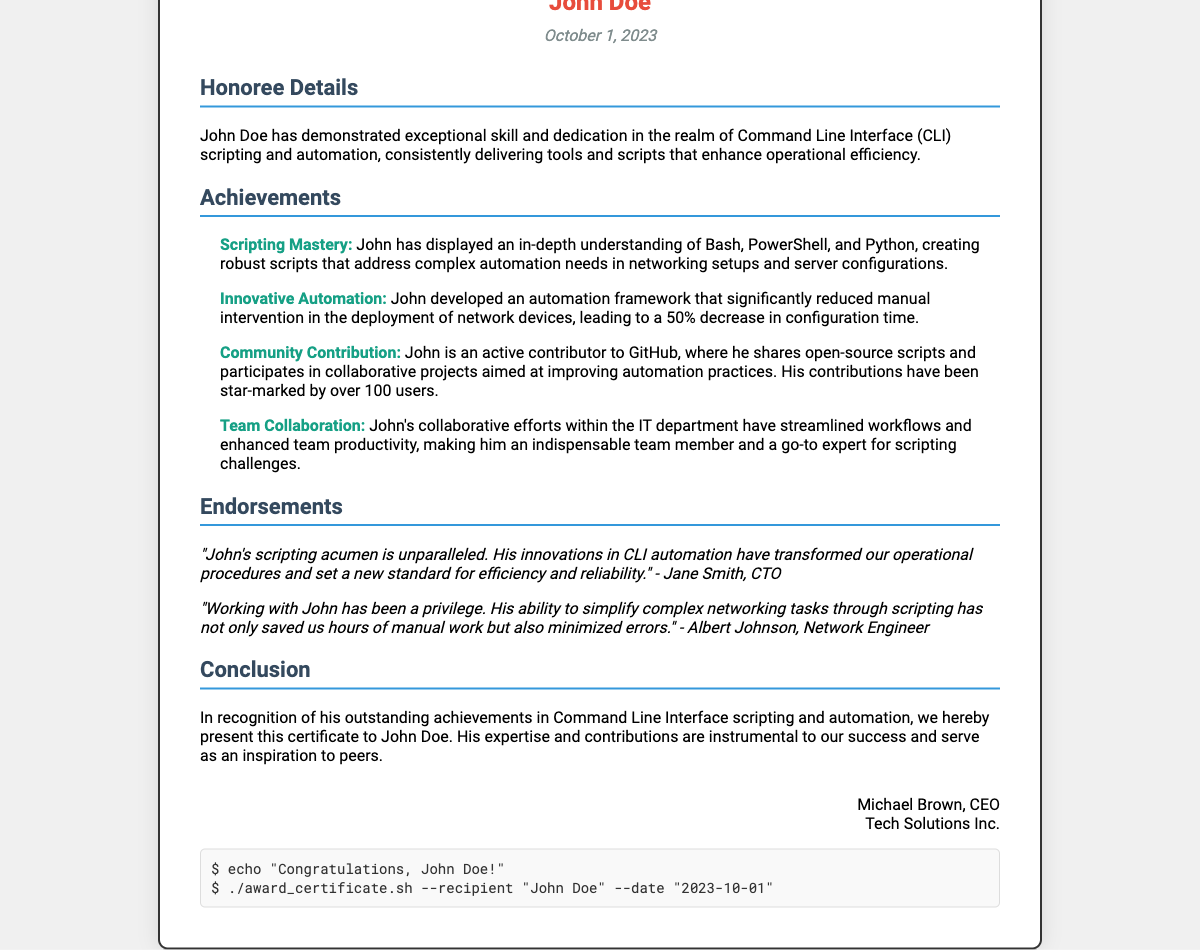What is the title of the certificate? The title clearly states the recognition given for CLI scripting and automation.
Answer: Recognition for Outstanding Command Line Interface Scripting and Automation Who is the recipient of the certificate? The document specifically names the individual who received the certificate.
Answer: John Doe What date is listed on the certificate? The document provides the exact date the certificate was awarded.
Answer: October 1, 2023 What programming languages are mentioned in the achievements? The document lists the programming languages in which the recipient has demonstrated skill.
Answer: Bash, PowerShell, Python What is the percentage decrease in configuration time due to automation? This information indicates the impact of the recipient's work on efficiency.
Answer: 50% Who is the CEO mentioned in the certificate? The document identifies the individual who signed the certificate as the CEO.
Answer: Michael Brown What contribution method is noted for the recipient on GitHub? The document highlights how the recipient engages with the community online.
Answer: Open-source scripts What is the main reason for awarding this certificate? The document summarizes the overall achievements of the recipient that led to this recognition.
Answer: Outstanding achievements in Command Line Interface scripting and automation 